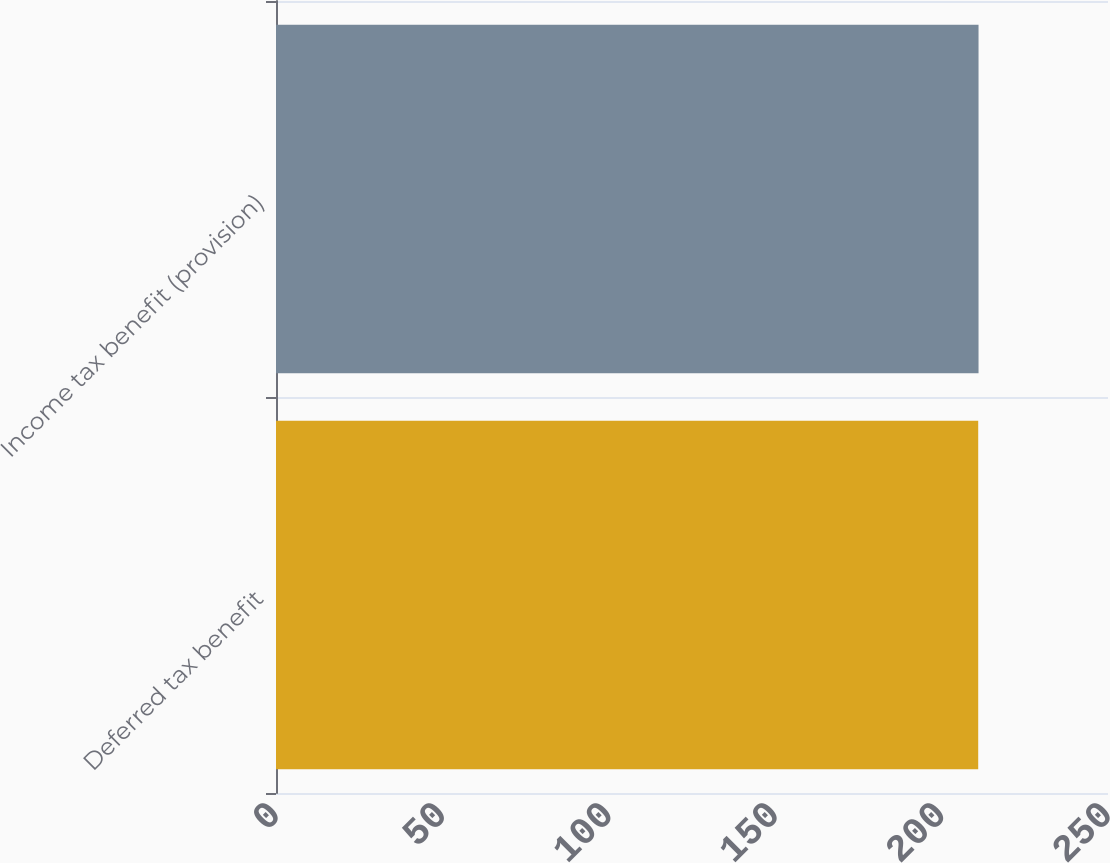Convert chart. <chart><loc_0><loc_0><loc_500><loc_500><bar_chart><fcel>Deferred tax benefit<fcel>Income tax benefit (provision)<nl><fcel>211<fcel>211.1<nl></chart> 